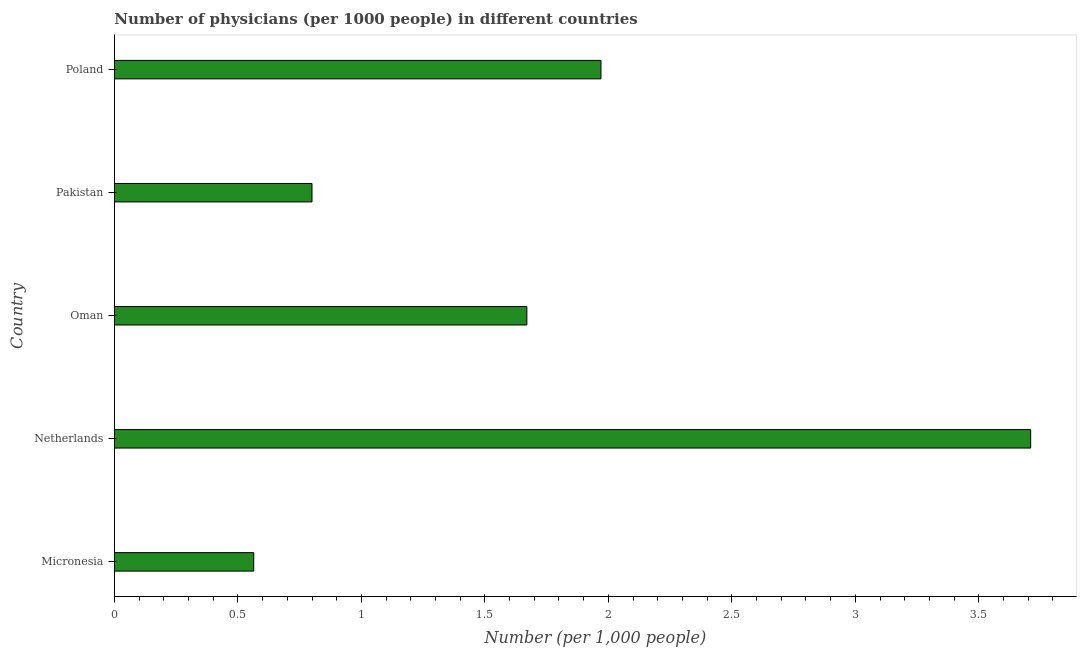What is the title of the graph?
Offer a very short reply. Number of physicians (per 1000 people) in different countries. What is the label or title of the X-axis?
Provide a short and direct response. Number (per 1,0 people). What is the label or title of the Y-axis?
Make the answer very short. Country. What is the number of physicians in Oman?
Your answer should be very brief. 1.67. Across all countries, what is the maximum number of physicians?
Give a very brief answer. 3.71. Across all countries, what is the minimum number of physicians?
Give a very brief answer. 0.56. In which country was the number of physicians minimum?
Provide a succinct answer. Micronesia. What is the sum of the number of physicians?
Provide a short and direct response. 8.71. What is the difference between the number of physicians in Micronesia and Netherlands?
Keep it short and to the point. -3.15. What is the average number of physicians per country?
Give a very brief answer. 1.74. What is the median number of physicians?
Keep it short and to the point. 1.67. What is the ratio of the number of physicians in Netherlands to that in Pakistan?
Your response must be concise. 4.64. Is the number of physicians in Micronesia less than that in Netherlands?
Provide a succinct answer. Yes. Is the difference between the number of physicians in Pakistan and Poland greater than the difference between any two countries?
Your response must be concise. No. What is the difference between the highest and the second highest number of physicians?
Provide a short and direct response. 1.74. What is the difference between the highest and the lowest number of physicians?
Your answer should be very brief. 3.15. In how many countries, is the number of physicians greater than the average number of physicians taken over all countries?
Provide a short and direct response. 2. Are all the bars in the graph horizontal?
Make the answer very short. Yes. How many countries are there in the graph?
Your response must be concise. 5. What is the difference between two consecutive major ticks on the X-axis?
Provide a succinct answer. 0.5. Are the values on the major ticks of X-axis written in scientific E-notation?
Give a very brief answer. No. What is the Number (per 1,000 people) in Micronesia?
Your response must be concise. 0.56. What is the Number (per 1,000 people) of Netherlands?
Your answer should be compact. 3.71. What is the Number (per 1,000 people) in Oman?
Provide a short and direct response. 1.67. What is the Number (per 1,000 people) in Poland?
Offer a very short reply. 1.97. What is the difference between the Number (per 1,000 people) in Micronesia and Netherlands?
Provide a short and direct response. -3.15. What is the difference between the Number (per 1,000 people) in Micronesia and Oman?
Your answer should be very brief. -1.11. What is the difference between the Number (per 1,000 people) in Micronesia and Pakistan?
Keep it short and to the point. -0.24. What is the difference between the Number (per 1,000 people) in Micronesia and Poland?
Ensure brevity in your answer.  -1.41. What is the difference between the Number (per 1,000 people) in Netherlands and Oman?
Your answer should be compact. 2.04. What is the difference between the Number (per 1,000 people) in Netherlands and Pakistan?
Your answer should be very brief. 2.91. What is the difference between the Number (per 1,000 people) in Netherlands and Poland?
Give a very brief answer. 1.74. What is the difference between the Number (per 1,000 people) in Oman and Pakistan?
Offer a terse response. 0.87. What is the difference between the Number (per 1,000 people) in Oman and Poland?
Ensure brevity in your answer.  -0.3. What is the difference between the Number (per 1,000 people) in Pakistan and Poland?
Keep it short and to the point. -1.17. What is the ratio of the Number (per 1,000 people) in Micronesia to that in Netherlands?
Keep it short and to the point. 0.15. What is the ratio of the Number (per 1,000 people) in Micronesia to that in Oman?
Your answer should be very brief. 0.34. What is the ratio of the Number (per 1,000 people) in Micronesia to that in Pakistan?
Offer a terse response. 0.7. What is the ratio of the Number (per 1,000 people) in Micronesia to that in Poland?
Provide a succinct answer. 0.29. What is the ratio of the Number (per 1,000 people) in Netherlands to that in Oman?
Provide a short and direct response. 2.22. What is the ratio of the Number (per 1,000 people) in Netherlands to that in Pakistan?
Your answer should be very brief. 4.64. What is the ratio of the Number (per 1,000 people) in Netherlands to that in Poland?
Provide a short and direct response. 1.88. What is the ratio of the Number (per 1,000 people) in Oman to that in Pakistan?
Offer a terse response. 2.09. What is the ratio of the Number (per 1,000 people) in Oman to that in Poland?
Ensure brevity in your answer.  0.85. What is the ratio of the Number (per 1,000 people) in Pakistan to that in Poland?
Ensure brevity in your answer.  0.41. 